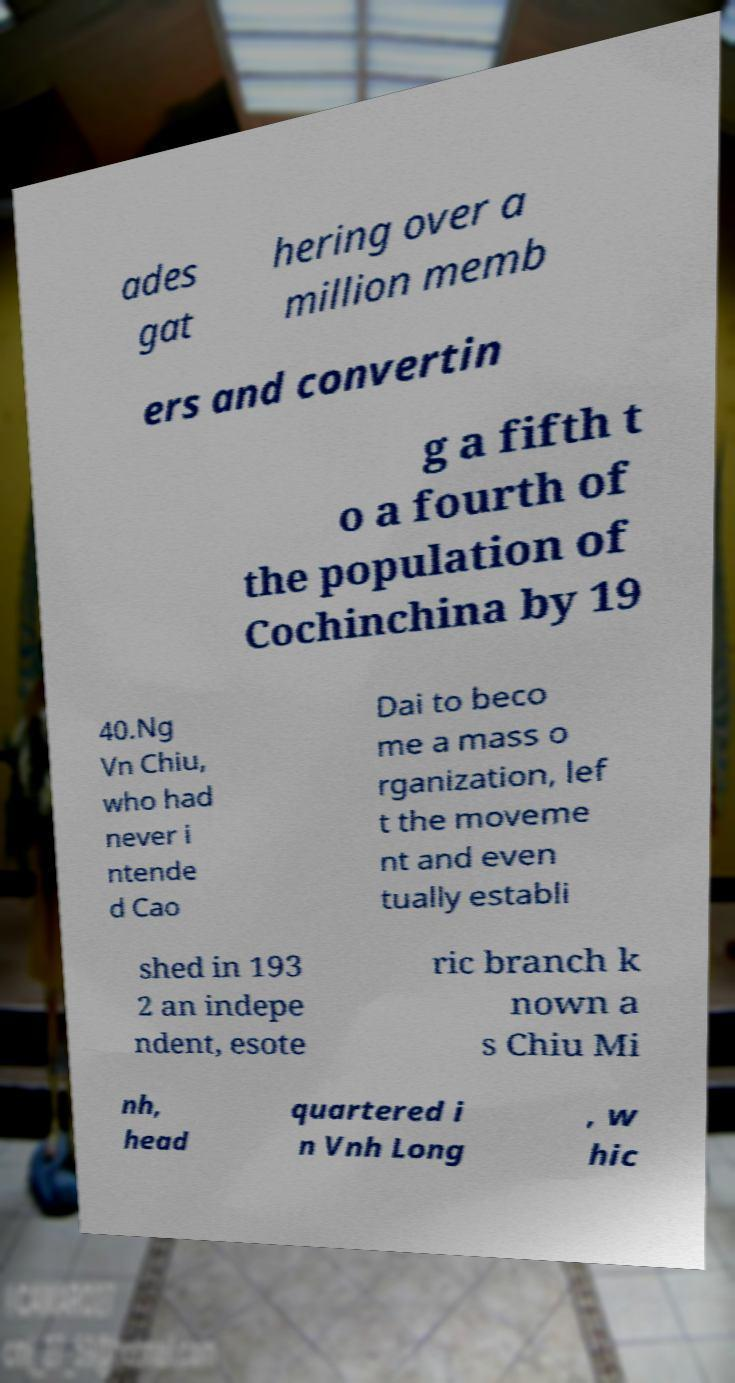Can you accurately transcribe the text from the provided image for me? ades gat hering over a million memb ers and convertin g a fifth t o a fourth of the population of Cochinchina by 19 40.Ng Vn Chiu, who had never i ntende d Cao Dai to beco me a mass o rganization, lef t the moveme nt and even tually establi shed in 193 2 an indepe ndent, esote ric branch k nown a s Chiu Mi nh, head quartered i n Vnh Long , w hic 